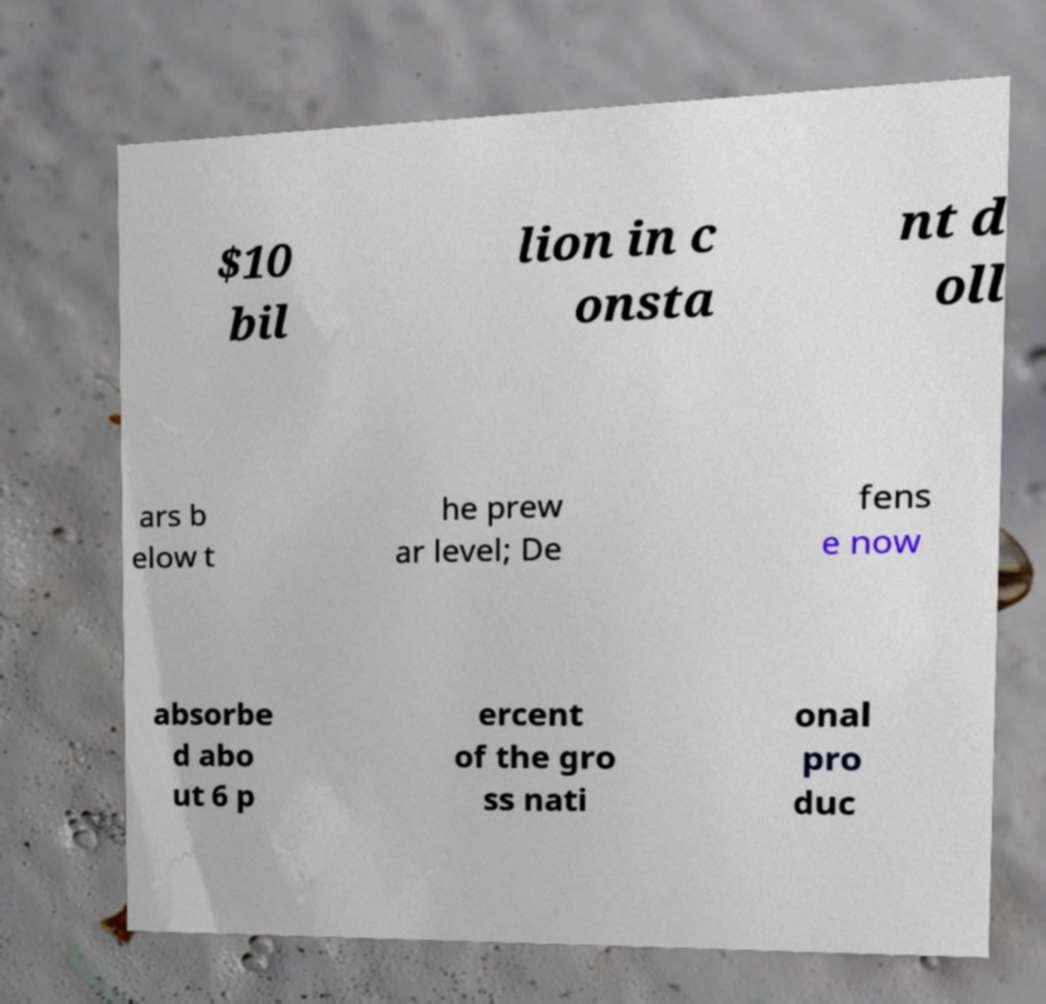I need the written content from this picture converted into text. Can you do that? $10 bil lion in c onsta nt d oll ars b elow t he prew ar level; De fens e now absorbe d abo ut 6 p ercent of the gro ss nati onal pro duc 